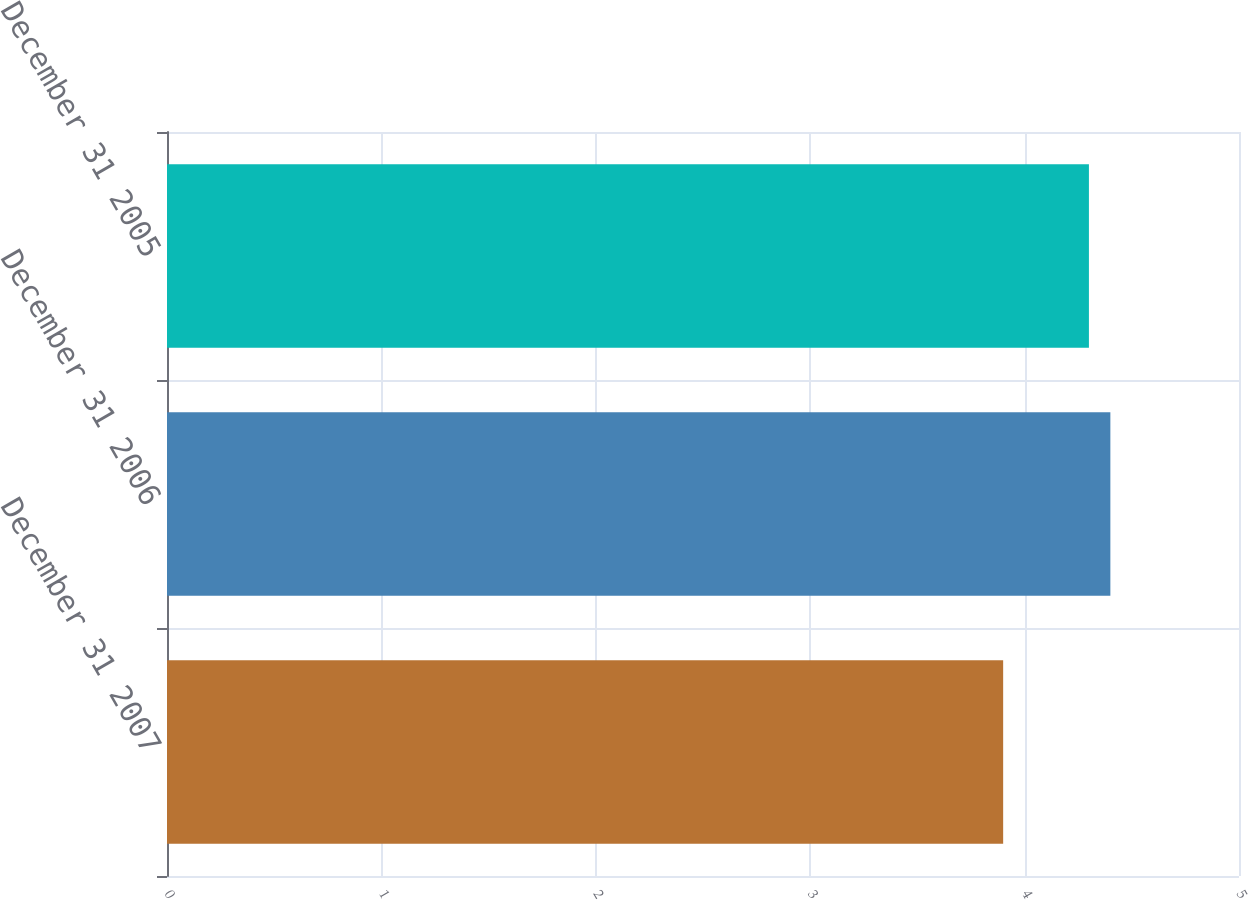<chart> <loc_0><loc_0><loc_500><loc_500><bar_chart><fcel>December 31 2007<fcel>December 31 2006<fcel>December 31 2005<nl><fcel>3.9<fcel>4.4<fcel>4.3<nl></chart> 